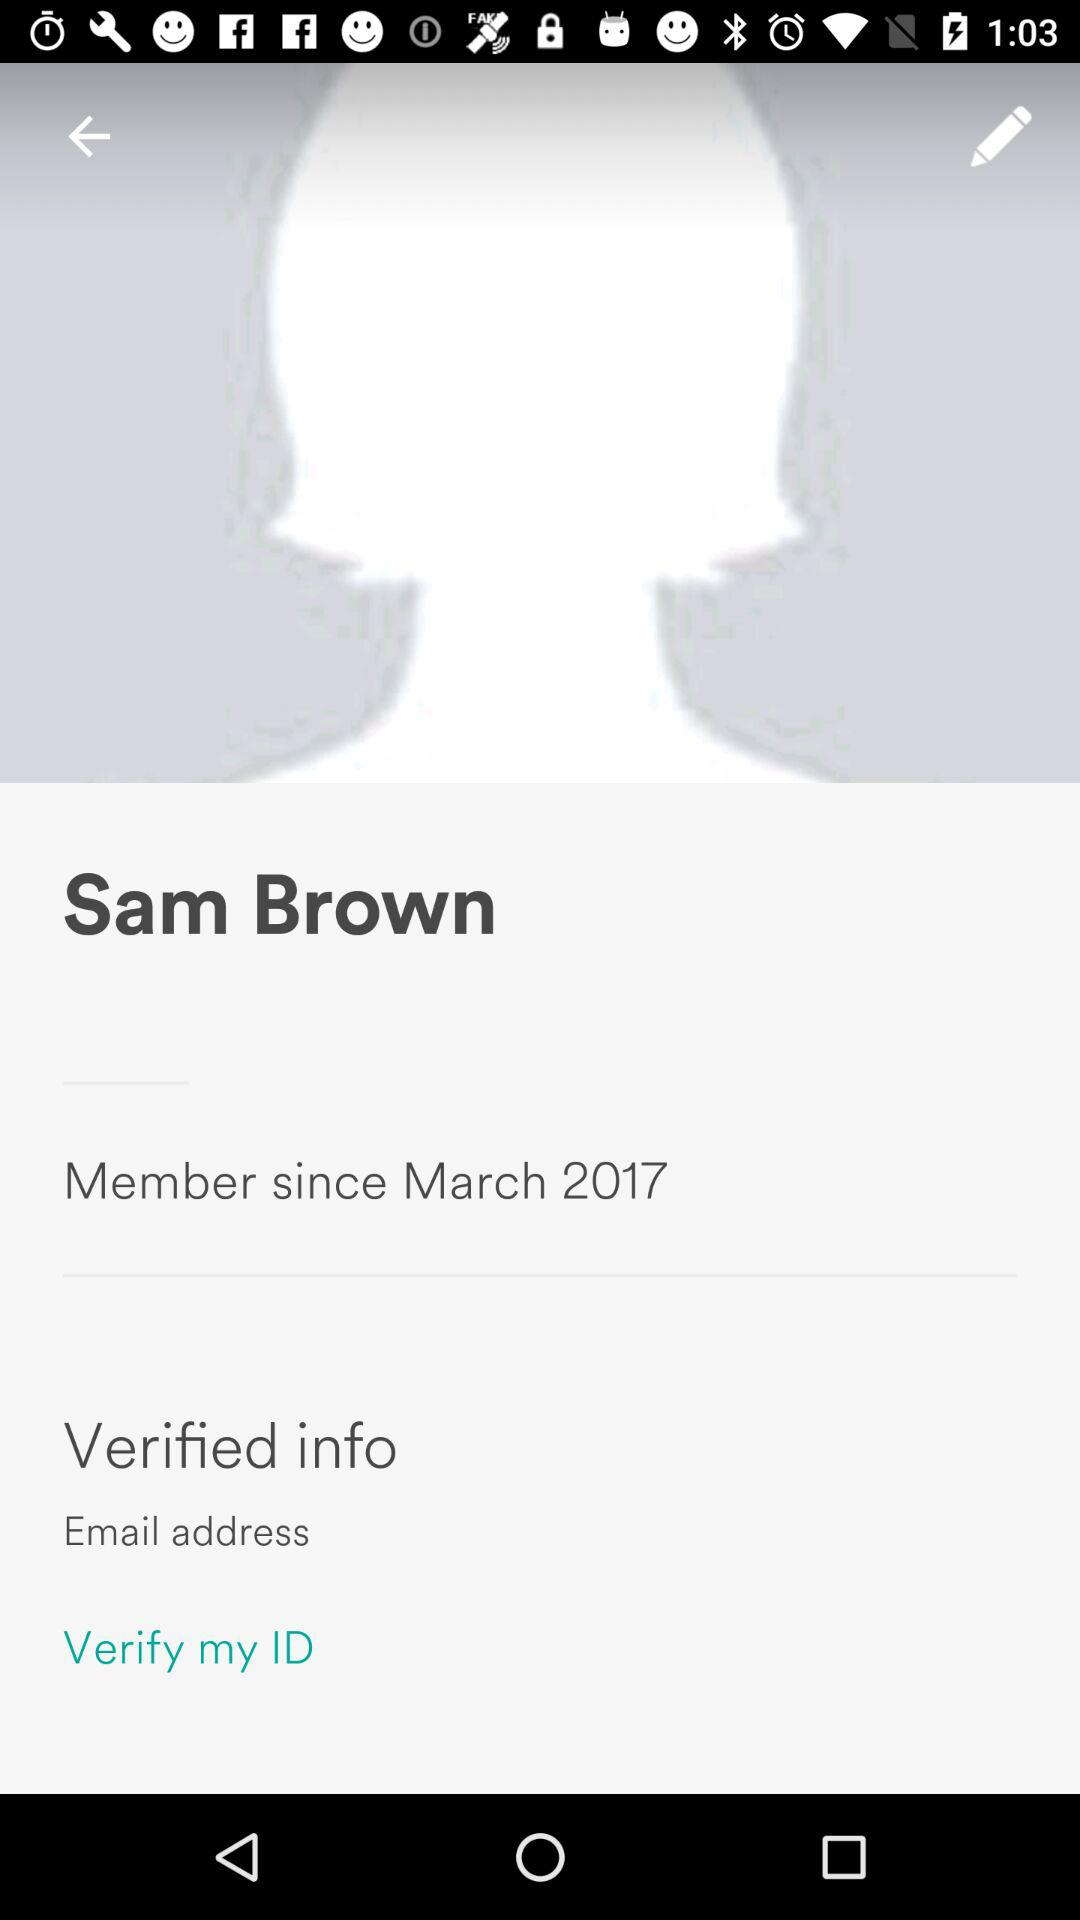Since when has Sam Brown been a member? Sam Brown has been a member since March 2017. 